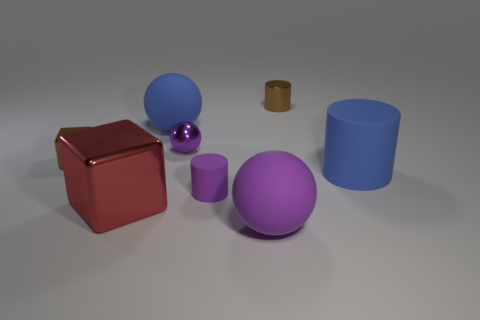Subtract all small cylinders. How many cylinders are left? 1 Subtract all yellow cylinders. How many purple spheres are left? 2 Subtract all blue spheres. How many spheres are left? 2 Subtract all blocks. How many objects are left? 6 Subtract 1 cylinders. How many cylinders are left? 2 Add 1 gray rubber spheres. How many objects exist? 9 Subtract all large purple rubber balls. Subtract all small blue metal objects. How many objects are left? 7 Add 7 large matte objects. How many large matte objects are left? 10 Add 5 brown rubber spheres. How many brown rubber spheres exist? 5 Subtract 1 brown cylinders. How many objects are left? 7 